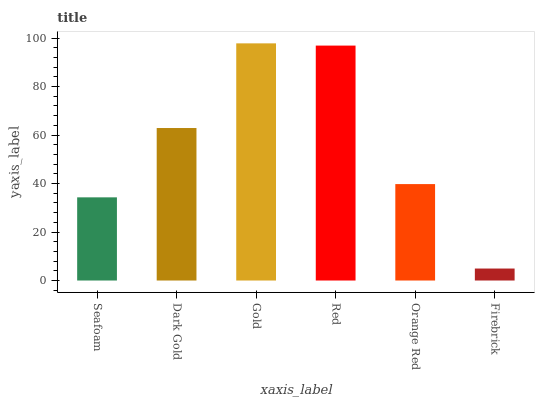Is Firebrick the minimum?
Answer yes or no. Yes. Is Gold the maximum?
Answer yes or no. Yes. Is Dark Gold the minimum?
Answer yes or no. No. Is Dark Gold the maximum?
Answer yes or no. No. Is Dark Gold greater than Seafoam?
Answer yes or no. Yes. Is Seafoam less than Dark Gold?
Answer yes or no. Yes. Is Seafoam greater than Dark Gold?
Answer yes or no. No. Is Dark Gold less than Seafoam?
Answer yes or no. No. Is Dark Gold the high median?
Answer yes or no. Yes. Is Orange Red the low median?
Answer yes or no. Yes. Is Gold the high median?
Answer yes or no. No. Is Dark Gold the low median?
Answer yes or no. No. 